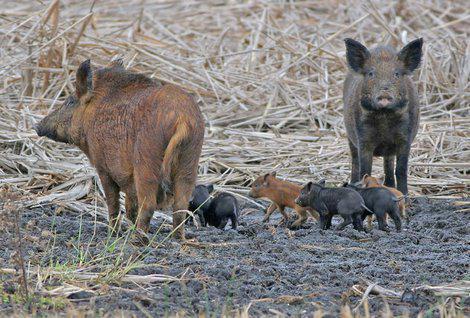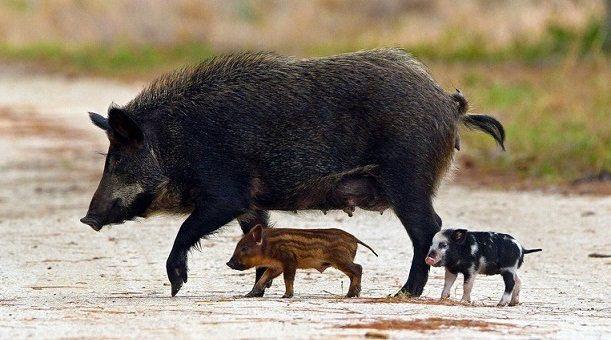The first image is the image on the left, the second image is the image on the right. Analyze the images presented: Is the assertion "In one of the image there are baby pigs near a mother pig" valid? Answer yes or no. Yes. 